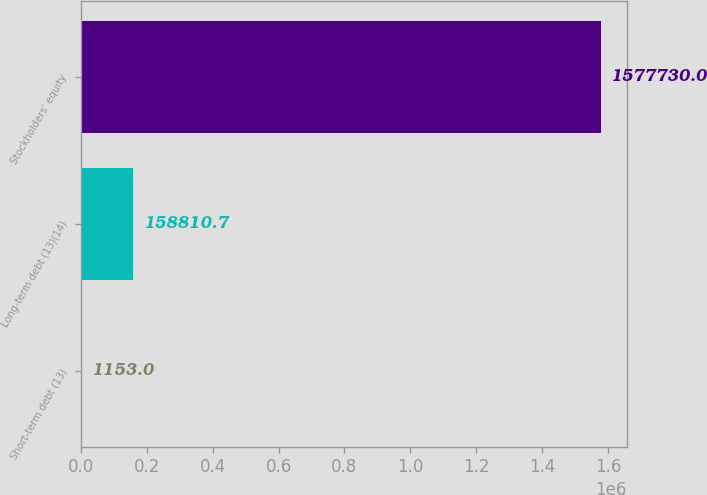Convert chart. <chart><loc_0><loc_0><loc_500><loc_500><bar_chart><fcel>Short-term debt (13)<fcel>Long-term debt (13)(14)<fcel>Stockholders' equity<nl><fcel>1153<fcel>158811<fcel>1.57773e+06<nl></chart> 